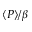Convert formula to latex. <formula><loc_0><loc_0><loc_500><loc_500>\langle P \rangle / \beta</formula> 